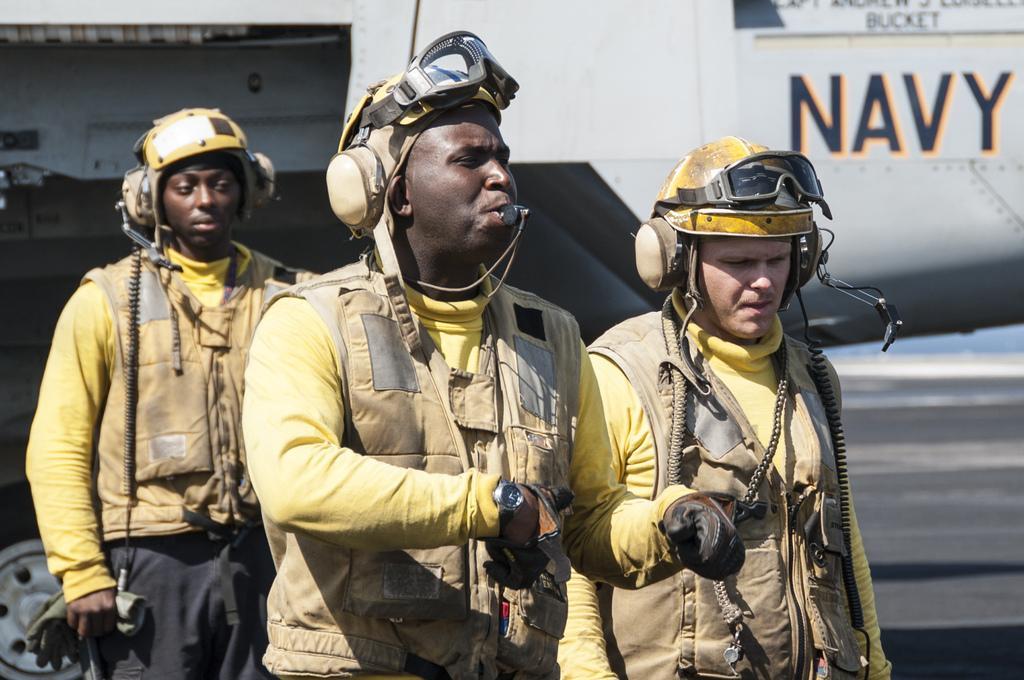How would you summarize this image in a sentence or two? In this image I can see three persons standing and they are wearing brown and yellow color dress. In front the person is wearing brown color gloves, background I can see and aircraft which is in white color and the sky is in blue color. 